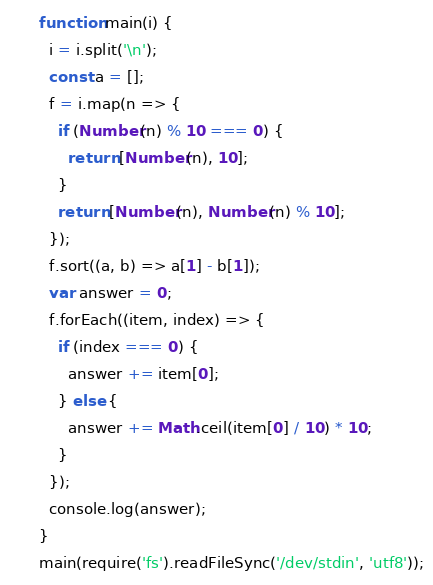<code> <loc_0><loc_0><loc_500><loc_500><_JavaScript_>function main(i) {
  i = i.split('\n');
  const a = [];
  f = i.map(n => {
    if (Number(n) % 10 === 0) {
      return [Number(n), 10];
    }
    return [Number(n), Number(n) % 10];
  });
  f.sort((a, b) => a[1] - b[1]);
  var answer = 0;
  f.forEach((item, index) => {
    if (index === 0) {
      answer += item[0];
    } else {
      answer += Math.ceil(item[0] / 10) * 10;
    }
  });
  console.log(answer);
}
main(require('fs').readFileSync('/dev/stdin', 'utf8'));</code> 